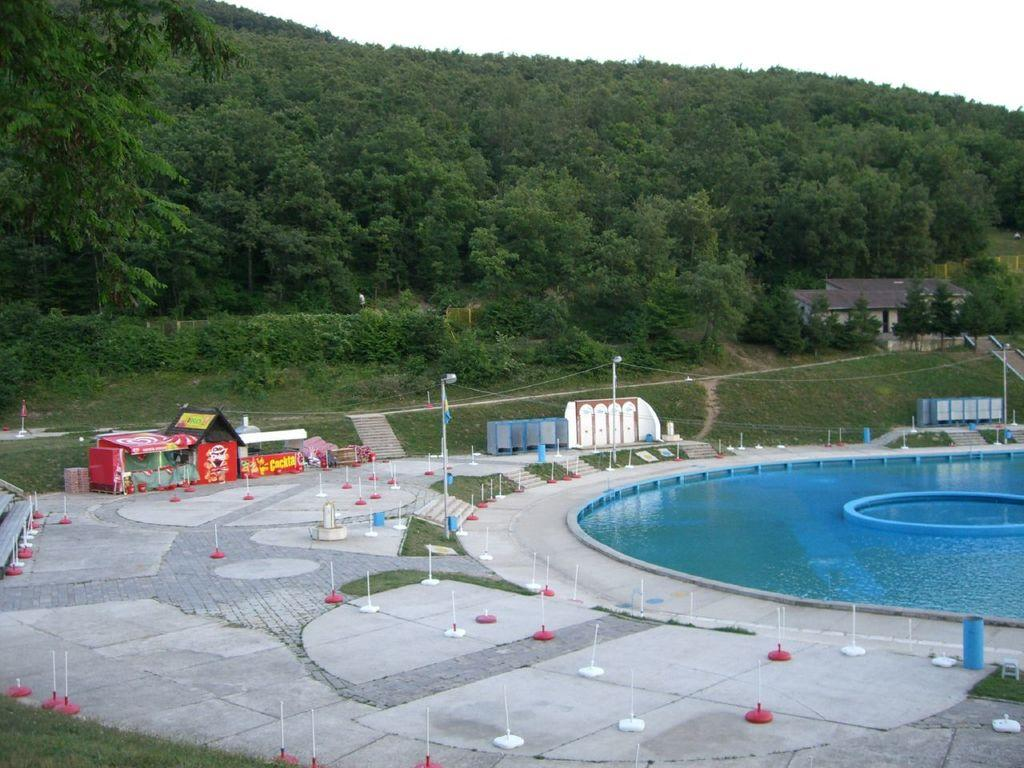What is the main feature in the image? There is a big pool in the image. What else can be seen on the ground in the image? There is a ground with poles and a stall on the ground. What is located in the background of the image? There is a mountain in the image, and it has many trees. Can you describe the building in the image? There is a building under the mountain in the image. What type of yam is being harvested in the plantation shown in the image? There is no plantation or yam present in the image; it features a big pool, a ground with poles, a stall, a mountain, and a building. 